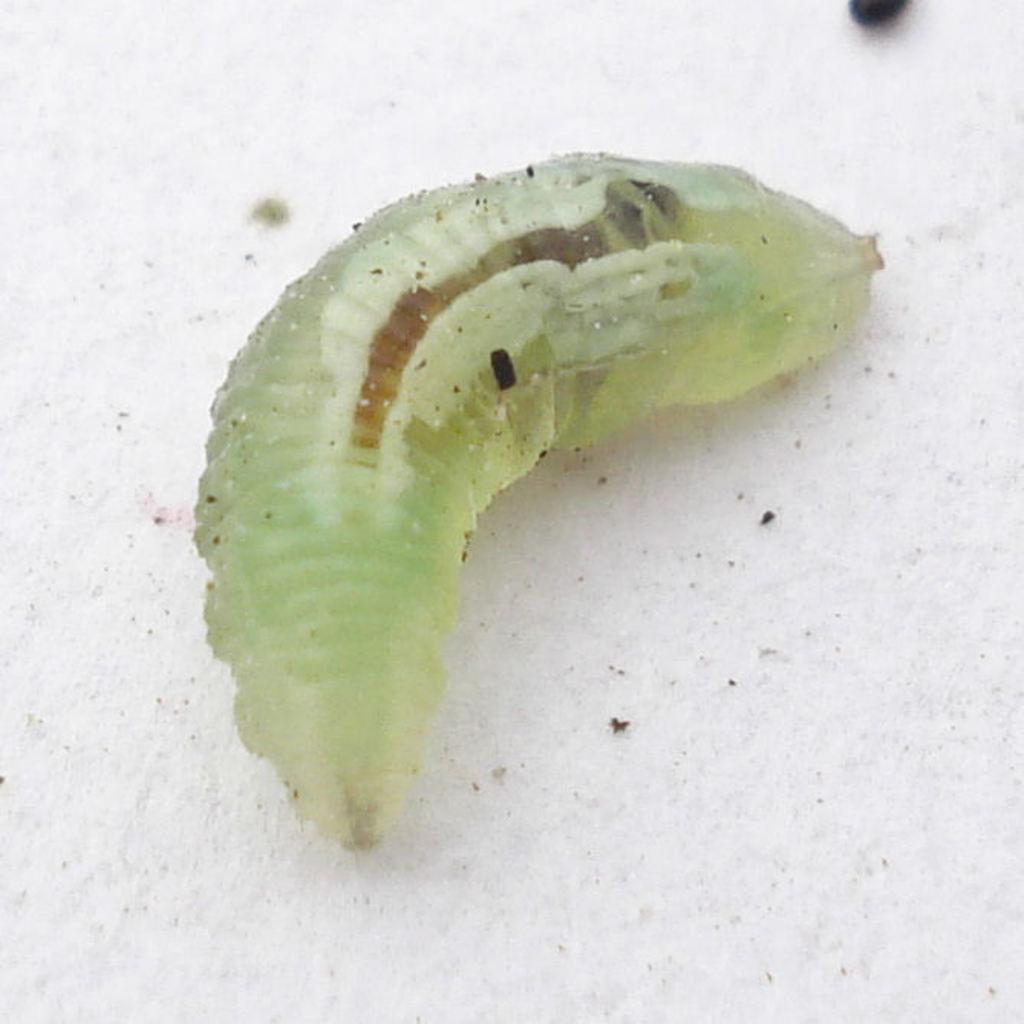Can you describe this image briefly? In this image there is an insect on the floor. 